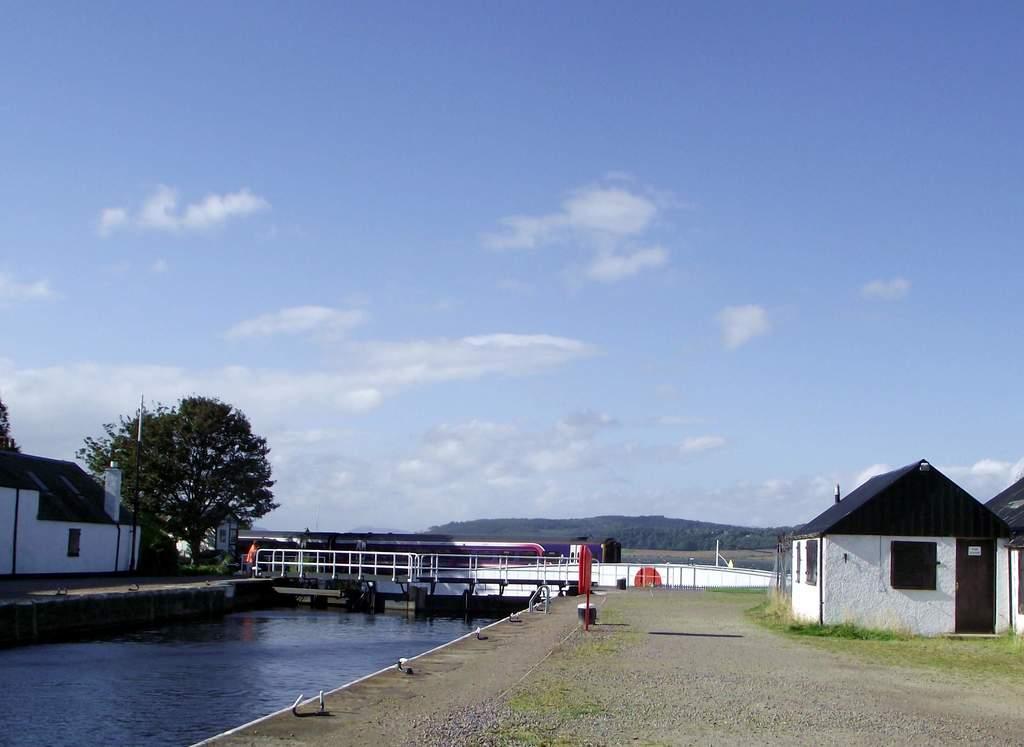In one or two sentences, can you explain what this image depicts? Here in this picture on the left side we can see a pool with full of water over there and we can also see a bridge over there and we can see houses present on either side and we can see trees over there and in the far we can see mountains and we can see clouds in the sky. 